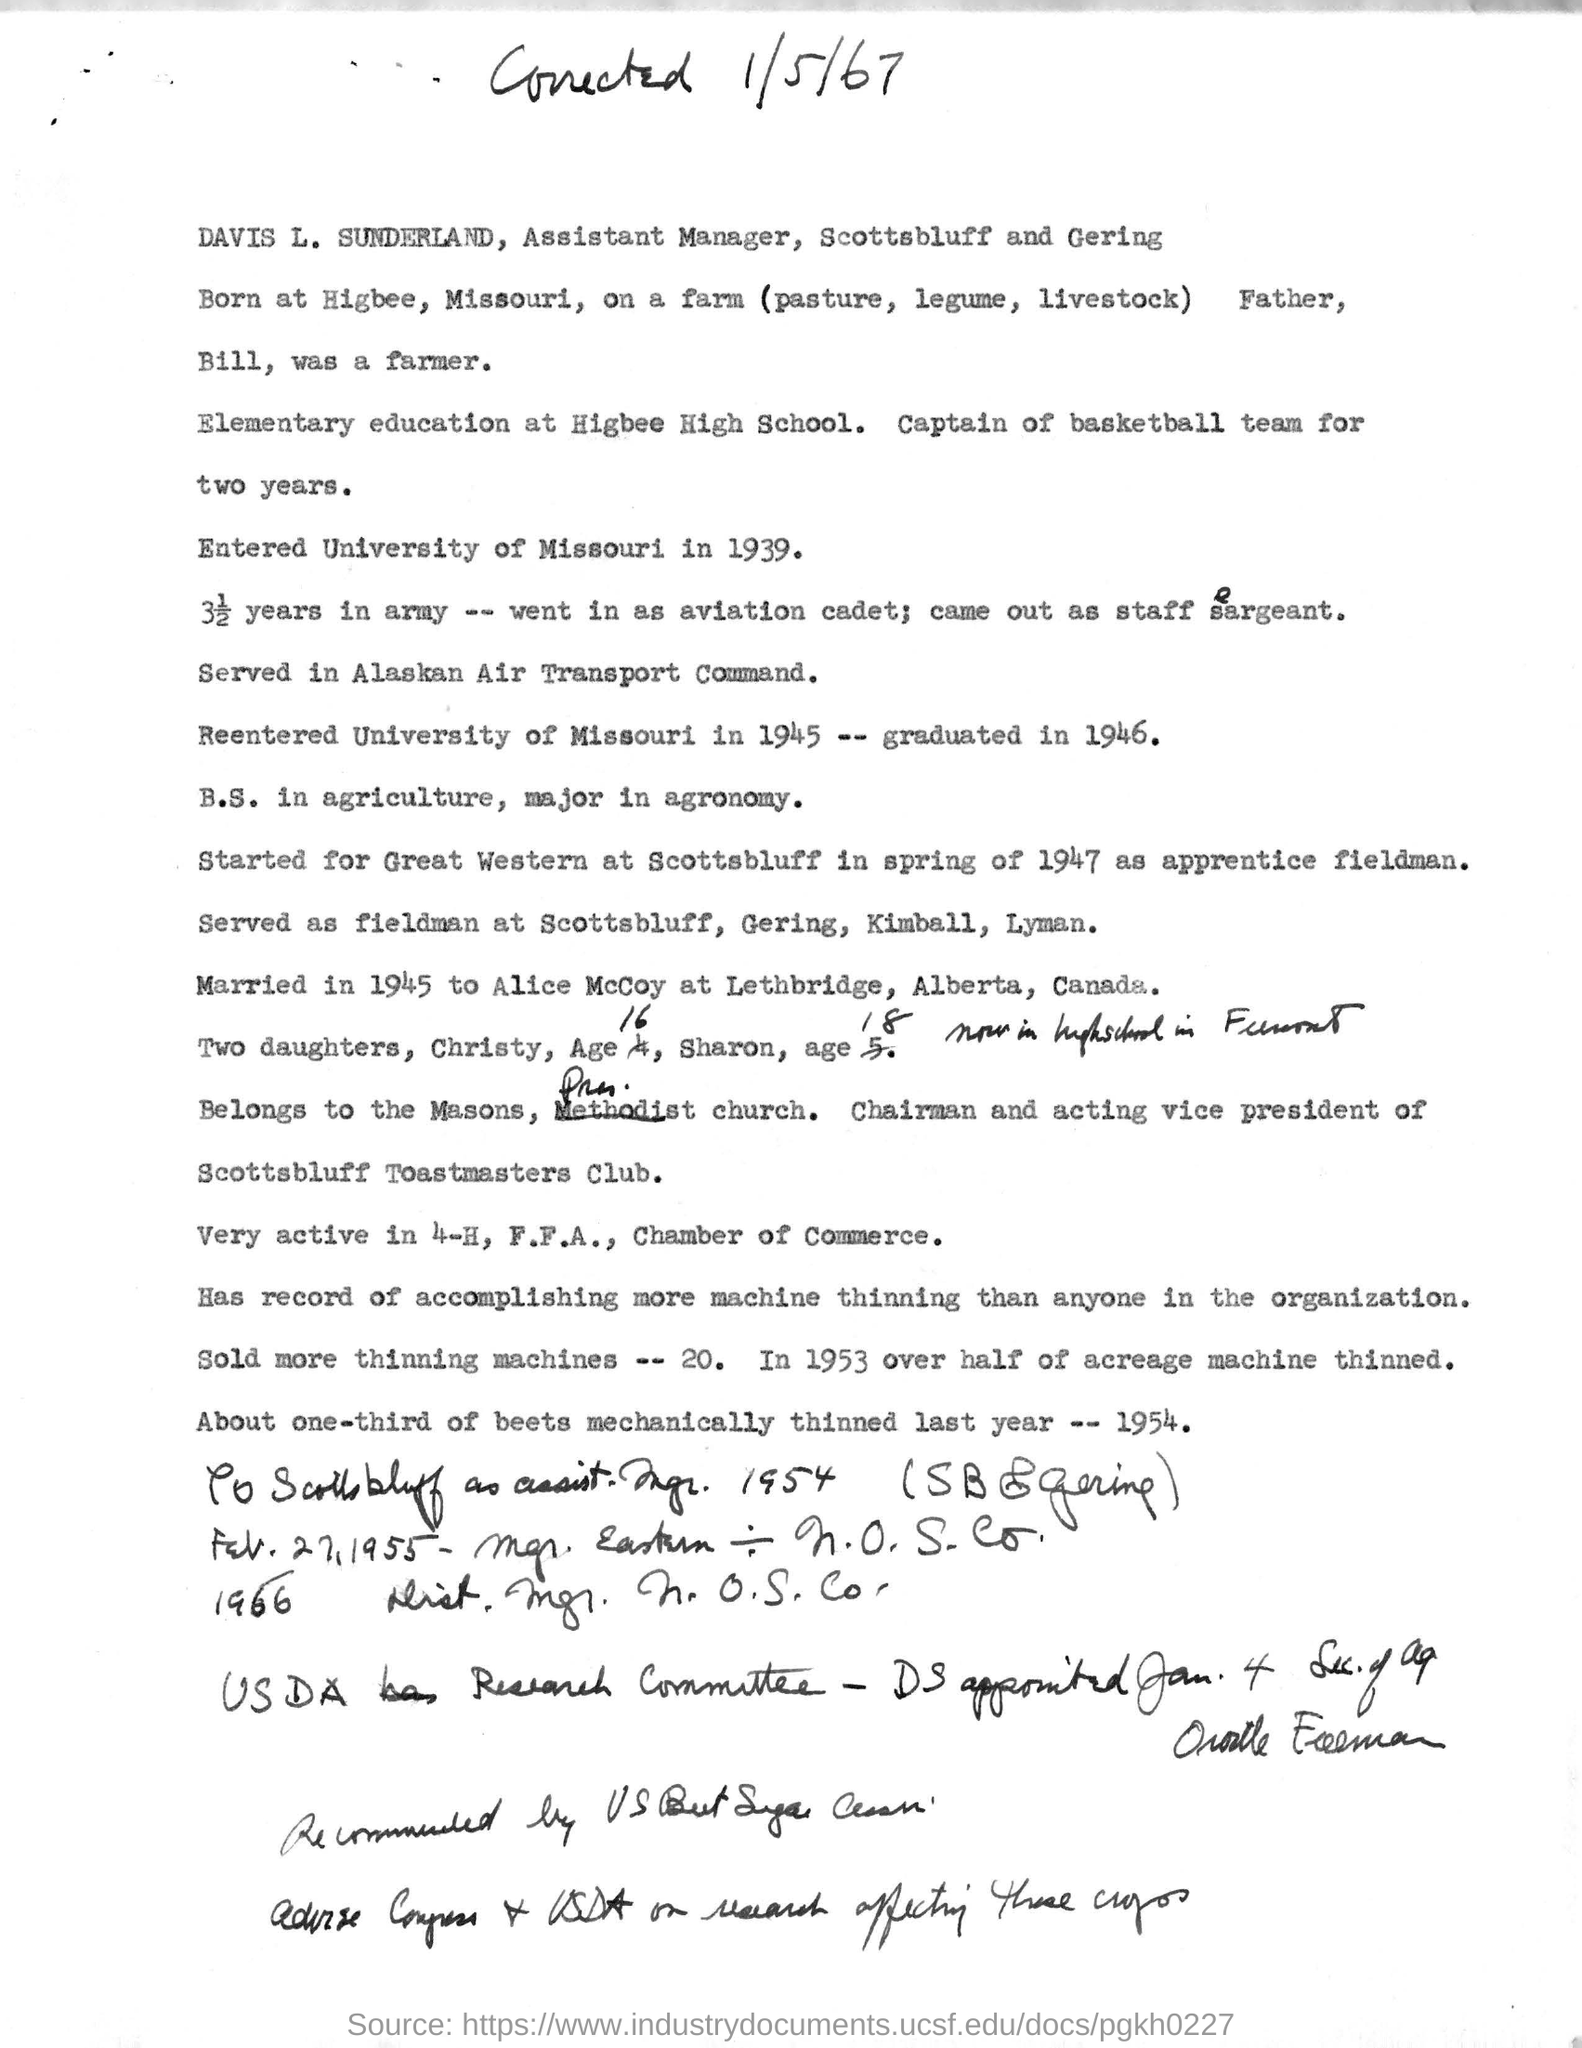What is the designation of Davis L. Sunderland?
Your answer should be very brief. Assistant Manager,Scottsbluff and Gering. 